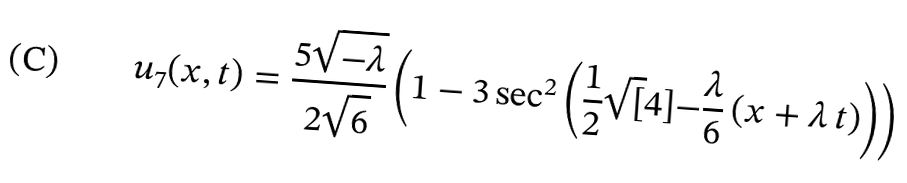Convert formula to latex. <formula><loc_0><loc_0><loc_500><loc_500>u _ { 7 } ( x , t ) = \frac { 5 \sqrt { - \lambda } } { 2 \sqrt { 6 } } \left ( 1 - 3 \, \text {sec} ^ { 2 } \left ( \frac { 1 } { 2 } \sqrt { [ } 4 ] { - \frac { \lambda } { 6 } } \, ( x + \lambda \, t ) \right ) \right )</formula> 